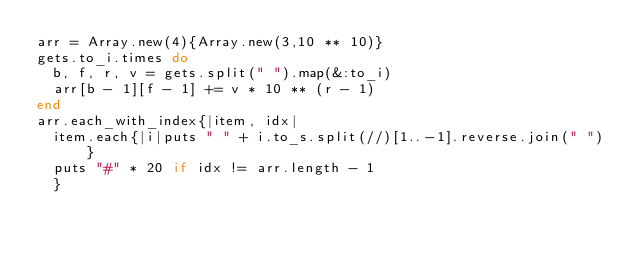Convert code to text. <code><loc_0><loc_0><loc_500><loc_500><_Ruby_>arr = Array.new(4){Array.new(3,10 ** 10)}
gets.to_i.times do
  b, f, r, v = gets.split(" ").map(&:to_i)
  arr[b - 1][f - 1] += v * 10 ** (r - 1)
end
arr.each_with_index{|item, idx|
  item.each{|i|puts " " + i.to_s.split(//)[1..-1].reverse.join(" ")}
  puts "#" * 20 if idx != arr.length - 1
  }
  </code> 